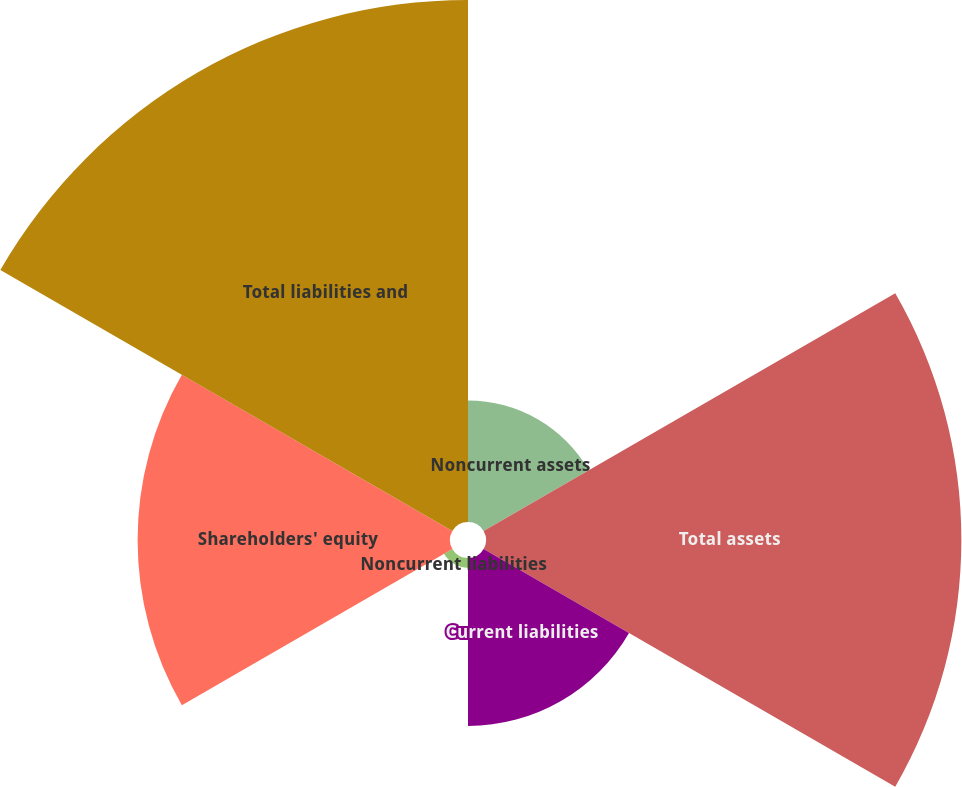Convert chart to OTSL. <chart><loc_0><loc_0><loc_500><loc_500><pie_chart><fcel>Noncurrent assets<fcel>Total assets<fcel>Current liabilities<fcel>Noncurrent liabilities<fcel>Shareholders' equity<fcel>Total liabilities and<nl><fcel>7.55%<fcel>29.55%<fcel>10.44%<fcel>0.6%<fcel>19.42%<fcel>32.45%<nl></chart> 